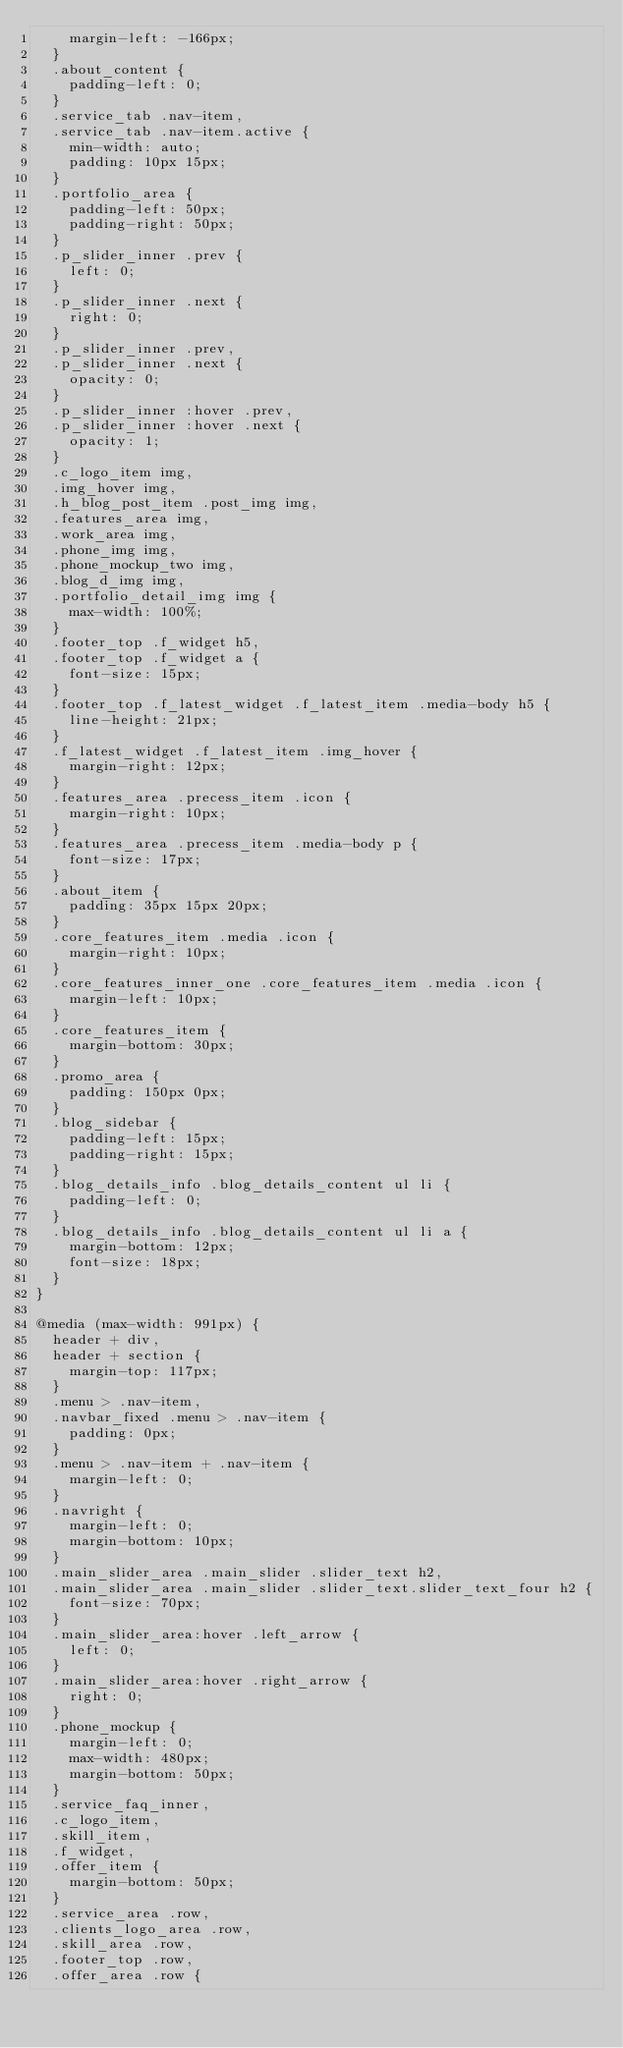<code> <loc_0><loc_0><loc_500><loc_500><_CSS_>    margin-left: -166px;
  }
  .about_content {
    padding-left: 0;
  }
  .service_tab .nav-item,
  .service_tab .nav-item.active {
    min-width: auto;
    padding: 10px 15px;
  }
  .portfolio_area {
    padding-left: 50px;
    padding-right: 50px;
  }
  .p_slider_inner .prev {
    left: 0;
  }
  .p_slider_inner .next {
    right: 0;
  }
  .p_slider_inner .prev,
  .p_slider_inner .next {
    opacity: 0;
  }
  .p_slider_inner :hover .prev,
  .p_slider_inner :hover .next {
    opacity: 1;
  }
  .c_logo_item img,
  .img_hover img,
  .h_blog_post_item .post_img img,
  .features_area img,
  .work_area img,
  .phone_img img,
  .phone_mockup_two img,
  .blog_d_img img,
  .portfolio_detail_img img {
    max-width: 100%;
  }
  .footer_top .f_widget h5,
  .footer_top .f_widget a {
    font-size: 15px;
  }
  .footer_top .f_latest_widget .f_latest_item .media-body h5 {
    line-height: 21px;
  }
  .f_latest_widget .f_latest_item .img_hover {
    margin-right: 12px;
  }
  .features_area .precess_item .icon {
    margin-right: 10px;
  }
  .features_area .precess_item .media-body p {
    font-size: 17px;
  }
  .about_item {
    padding: 35px 15px 20px;
  }
  .core_features_item .media .icon {
    margin-right: 10px;
  }
  .core_features_inner_one .core_features_item .media .icon {
    margin-left: 10px;
  }
  .core_features_item {
    margin-bottom: 30px;
  }
  .promo_area {
    padding: 150px 0px;
  }
  .blog_sidebar {
    padding-left: 15px;
    padding-right: 15px;
  }
  .blog_details_info .blog_details_content ul li {
    padding-left: 0;
  }
  .blog_details_info .blog_details_content ul li a {
    margin-bottom: 12px;
    font-size: 18px;
  }
}

@media (max-width: 991px) {
  header + div,
  header + section {
    margin-top: 117px;
  }
  .menu > .nav-item,
  .navbar_fixed .menu > .nav-item {
    padding: 0px;
  }
  .menu > .nav-item + .nav-item {
    margin-left: 0;
  }
  .navright {
    margin-left: 0;
    margin-bottom: 10px;
  }
  .main_slider_area .main_slider .slider_text h2,
  .main_slider_area .main_slider .slider_text.slider_text_four h2 {
    font-size: 70px;
  }
  .main_slider_area:hover .left_arrow {
    left: 0;
  }
  .main_slider_area:hover .right_arrow {
    right: 0;
  }
  .phone_mockup {
    margin-left: 0;
    max-width: 480px;
    margin-bottom: 50px;
  }
  .service_faq_inner,
  .c_logo_item,
  .skill_item,
  .f_widget,
  .offer_item {
    margin-bottom: 50px;
  }
  .service_area .row,
  .clients_logo_area .row,
  .skill_area .row,
  .footer_top .row,
  .offer_area .row {</code> 